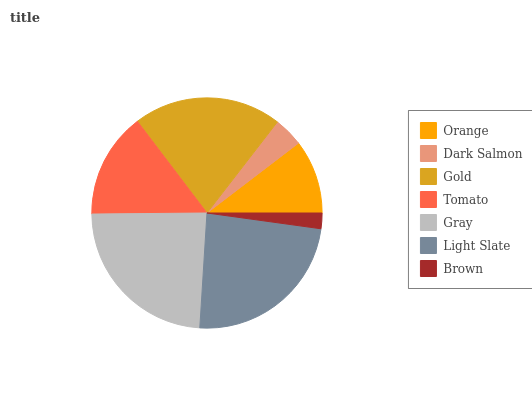Is Brown the minimum?
Answer yes or no. Yes. Is Gray the maximum?
Answer yes or no. Yes. Is Dark Salmon the minimum?
Answer yes or no. No. Is Dark Salmon the maximum?
Answer yes or no. No. Is Orange greater than Dark Salmon?
Answer yes or no. Yes. Is Dark Salmon less than Orange?
Answer yes or no. Yes. Is Dark Salmon greater than Orange?
Answer yes or no. No. Is Orange less than Dark Salmon?
Answer yes or no. No. Is Tomato the high median?
Answer yes or no. Yes. Is Tomato the low median?
Answer yes or no. Yes. Is Dark Salmon the high median?
Answer yes or no. No. Is Gold the low median?
Answer yes or no. No. 